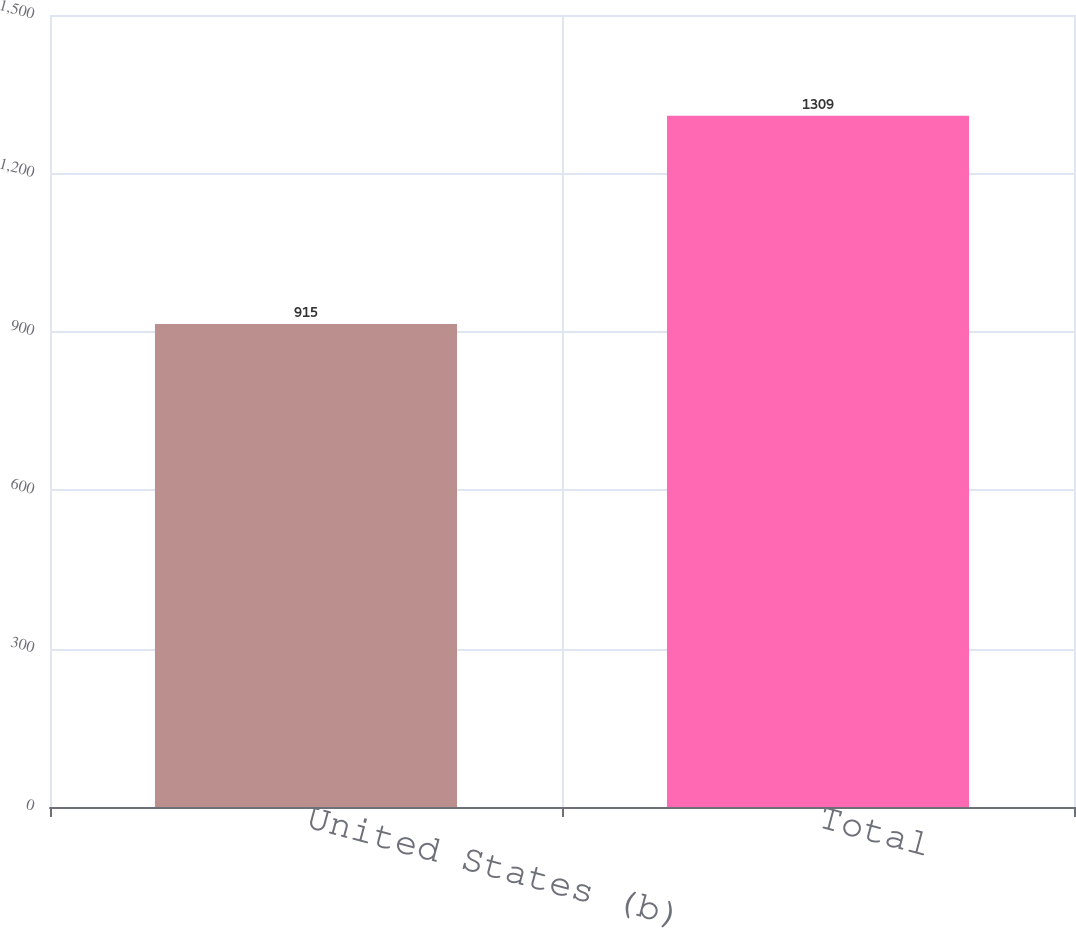Convert chart to OTSL. <chart><loc_0><loc_0><loc_500><loc_500><bar_chart><fcel>United States (b)<fcel>Total<nl><fcel>915<fcel>1309<nl></chart> 